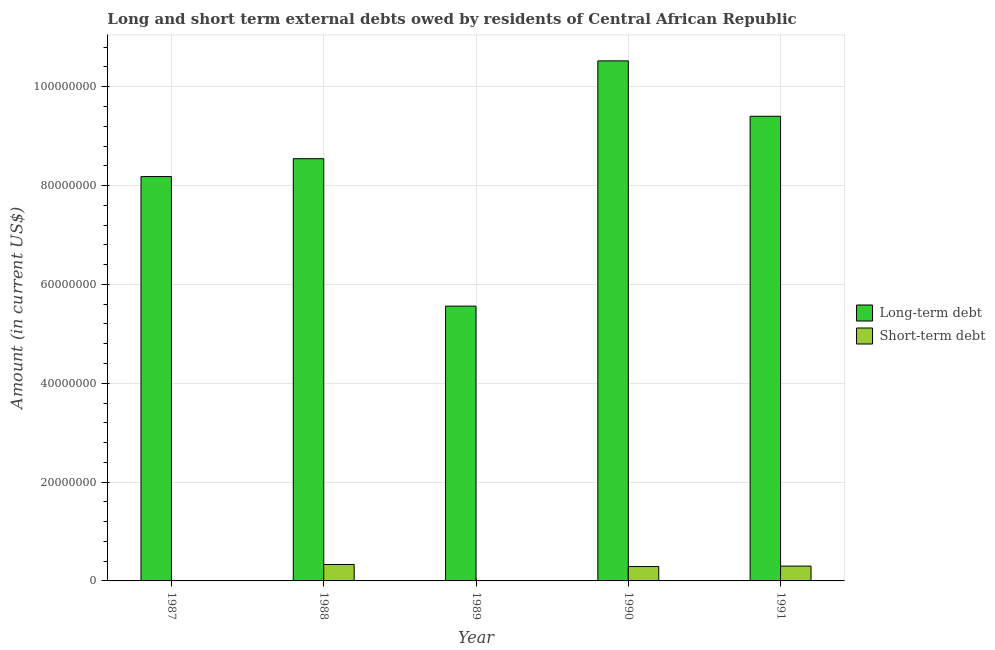How many different coloured bars are there?
Your answer should be very brief. 2. Are the number of bars on each tick of the X-axis equal?
Offer a very short reply. No. How many bars are there on the 5th tick from the left?
Offer a terse response. 2. How many bars are there on the 4th tick from the right?
Ensure brevity in your answer.  2. What is the long-term debts owed by residents in 1991?
Your answer should be very brief. 9.40e+07. Across all years, what is the maximum short-term debts owed by residents?
Make the answer very short. 3.33e+06. Across all years, what is the minimum long-term debts owed by residents?
Keep it short and to the point. 5.56e+07. In which year was the short-term debts owed by residents maximum?
Ensure brevity in your answer.  1988. What is the total long-term debts owed by residents in the graph?
Offer a terse response. 4.22e+08. What is the difference between the long-term debts owed by residents in 1987 and that in 1991?
Your answer should be very brief. -1.22e+07. What is the difference between the short-term debts owed by residents in 1990 and the long-term debts owed by residents in 1989?
Keep it short and to the point. 2.91e+06. What is the average short-term debts owed by residents per year?
Your answer should be very brief. 1.85e+06. In the year 1988, what is the difference between the long-term debts owed by residents and short-term debts owed by residents?
Offer a terse response. 0. In how many years, is the long-term debts owed by residents greater than 100000000 US$?
Offer a terse response. 1. What is the ratio of the short-term debts owed by residents in 1988 to that in 1990?
Offer a terse response. 1.14. What is the difference between the highest and the second highest long-term debts owed by residents?
Your answer should be very brief. 1.12e+07. What is the difference between the highest and the lowest short-term debts owed by residents?
Provide a short and direct response. 3.33e+06. In how many years, is the long-term debts owed by residents greater than the average long-term debts owed by residents taken over all years?
Ensure brevity in your answer.  3. What is the difference between two consecutive major ticks on the Y-axis?
Provide a succinct answer. 2.00e+07. Does the graph contain any zero values?
Your answer should be compact. Yes. Does the graph contain grids?
Your response must be concise. Yes. Where does the legend appear in the graph?
Keep it short and to the point. Center right. What is the title of the graph?
Provide a succinct answer. Long and short term external debts owed by residents of Central African Republic. Does "Food and tobacco" appear as one of the legend labels in the graph?
Provide a short and direct response. No. What is the label or title of the Y-axis?
Give a very brief answer. Amount (in current US$). What is the Amount (in current US$) in Long-term debt in 1987?
Ensure brevity in your answer.  8.18e+07. What is the Amount (in current US$) in Long-term debt in 1988?
Provide a succinct answer. 8.54e+07. What is the Amount (in current US$) in Short-term debt in 1988?
Offer a very short reply. 3.33e+06. What is the Amount (in current US$) of Long-term debt in 1989?
Give a very brief answer. 5.56e+07. What is the Amount (in current US$) of Long-term debt in 1990?
Your answer should be very brief. 1.05e+08. What is the Amount (in current US$) of Short-term debt in 1990?
Offer a terse response. 2.91e+06. What is the Amount (in current US$) of Long-term debt in 1991?
Offer a terse response. 9.40e+07. What is the Amount (in current US$) in Short-term debt in 1991?
Your answer should be very brief. 3.00e+06. Across all years, what is the maximum Amount (in current US$) in Long-term debt?
Your answer should be compact. 1.05e+08. Across all years, what is the maximum Amount (in current US$) in Short-term debt?
Make the answer very short. 3.33e+06. Across all years, what is the minimum Amount (in current US$) of Long-term debt?
Your answer should be very brief. 5.56e+07. Across all years, what is the minimum Amount (in current US$) in Short-term debt?
Offer a very short reply. 0. What is the total Amount (in current US$) of Long-term debt in the graph?
Provide a short and direct response. 4.22e+08. What is the total Amount (in current US$) of Short-term debt in the graph?
Give a very brief answer. 9.24e+06. What is the difference between the Amount (in current US$) of Long-term debt in 1987 and that in 1988?
Offer a very short reply. -3.61e+06. What is the difference between the Amount (in current US$) in Long-term debt in 1987 and that in 1989?
Offer a terse response. 2.62e+07. What is the difference between the Amount (in current US$) of Long-term debt in 1987 and that in 1990?
Offer a terse response. -2.34e+07. What is the difference between the Amount (in current US$) in Long-term debt in 1987 and that in 1991?
Make the answer very short. -1.22e+07. What is the difference between the Amount (in current US$) in Long-term debt in 1988 and that in 1989?
Ensure brevity in your answer.  2.98e+07. What is the difference between the Amount (in current US$) of Long-term debt in 1988 and that in 1990?
Offer a terse response. -1.98e+07. What is the difference between the Amount (in current US$) of Long-term debt in 1988 and that in 1991?
Your answer should be compact. -8.59e+06. What is the difference between the Amount (in current US$) of Long-term debt in 1989 and that in 1990?
Offer a terse response. -4.96e+07. What is the difference between the Amount (in current US$) of Long-term debt in 1989 and that in 1991?
Give a very brief answer. -3.84e+07. What is the difference between the Amount (in current US$) in Long-term debt in 1990 and that in 1991?
Your answer should be compact. 1.12e+07. What is the difference between the Amount (in current US$) in Long-term debt in 1987 and the Amount (in current US$) in Short-term debt in 1988?
Give a very brief answer. 7.85e+07. What is the difference between the Amount (in current US$) of Long-term debt in 1987 and the Amount (in current US$) of Short-term debt in 1990?
Keep it short and to the point. 7.89e+07. What is the difference between the Amount (in current US$) of Long-term debt in 1987 and the Amount (in current US$) of Short-term debt in 1991?
Your answer should be compact. 7.88e+07. What is the difference between the Amount (in current US$) of Long-term debt in 1988 and the Amount (in current US$) of Short-term debt in 1990?
Offer a terse response. 8.25e+07. What is the difference between the Amount (in current US$) in Long-term debt in 1988 and the Amount (in current US$) in Short-term debt in 1991?
Provide a short and direct response. 8.24e+07. What is the difference between the Amount (in current US$) of Long-term debt in 1989 and the Amount (in current US$) of Short-term debt in 1990?
Offer a very short reply. 5.27e+07. What is the difference between the Amount (in current US$) in Long-term debt in 1989 and the Amount (in current US$) in Short-term debt in 1991?
Provide a succinct answer. 5.26e+07. What is the difference between the Amount (in current US$) in Long-term debt in 1990 and the Amount (in current US$) in Short-term debt in 1991?
Make the answer very short. 1.02e+08. What is the average Amount (in current US$) in Long-term debt per year?
Make the answer very short. 8.44e+07. What is the average Amount (in current US$) of Short-term debt per year?
Give a very brief answer. 1.85e+06. In the year 1988, what is the difference between the Amount (in current US$) in Long-term debt and Amount (in current US$) in Short-term debt?
Provide a succinct answer. 8.21e+07. In the year 1990, what is the difference between the Amount (in current US$) in Long-term debt and Amount (in current US$) in Short-term debt?
Make the answer very short. 1.02e+08. In the year 1991, what is the difference between the Amount (in current US$) of Long-term debt and Amount (in current US$) of Short-term debt?
Provide a succinct answer. 9.10e+07. What is the ratio of the Amount (in current US$) in Long-term debt in 1987 to that in 1988?
Your response must be concise. 0.96. What is the ratio of the Amount (in current US$) in Long-term debt in 1987 to that in 1989?
Ensure brevity in your answer.  1.47. What is the ratio of the Amount (in current US$) of Long-term debt in 1987 to that in 1990?
Make the answer very short. 0.78. What is the ratio of the Amount (in current US$) of Long-term debt in 1987 to that in 1991?
Keep it short and to the point. 0.87. What is the ratio of the Amount (in current US$) of Long-term debt in 1988 to that in 1989?
Your answer should be compact. 1.54. What is the ratio of the Amount (in current US$) of Long-term debt in 1988 to that in 1990?
Offer a terse response. 0.81. What is the ratio of the Amount (in current US$) in Short-term debt in 1988 to that in 1990?
Offer a terse response. 1.14. What is the ratio of the Amount (in current US$) in Long-term debt in 1988 to that in 1991?
Your answer should be very brief. 0.91. What is the ratio of the Amount (in current US$) of Short-term debt in 1988 to that in 1991?
Make the answer very short. 1.11. What is the ratio of the Amount (in current US$) in Long-term debt in 1989 to that in 1990?
Provide a short and direct response. 0.53. What is the ratio of the Amount (in current US$) of Long-term debt in 1989 to that in 1991?
Keep it short and to the point. 0.59. What is the ratio of the Amount (in current US$) of Long-term debt in 1990 to that in 1991?
Make the answer very short. 1.12. What is the ratio of the Amount (in current US$) of Short-term debt in 1990 to that in 1991?
Your answer should be very brief. 0.97. What is the difference between the highest and the second highest Amount (in current US$) of Long-term debt?
Make the answer very short. 1.12e+07. What is the difference between the highest and the lowest Amount (in current US$) of Long-term debt?
Offer a very short reply. 4.96e+07. What is the difference between the highest and the lowest Amount (in current US$) in Short-term debt?
Give a very brief answer. 3.33e+06. 